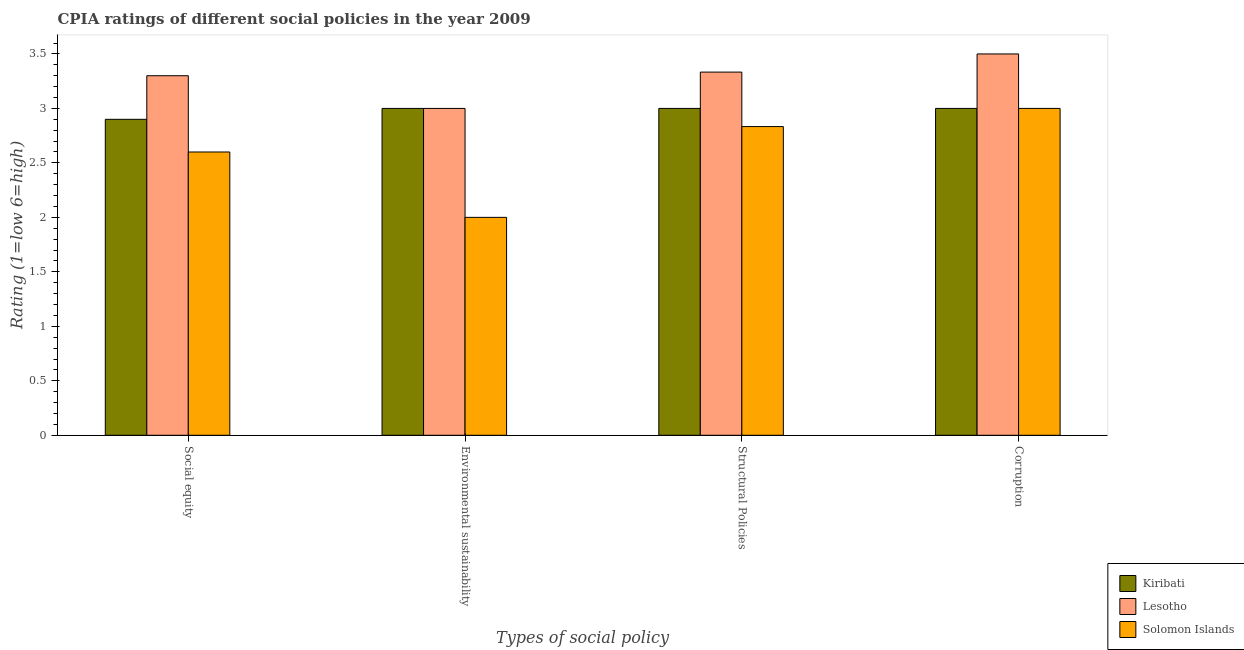How many groups of bars are there?
Your answer should be compact. 4. Are the number of bars on each tick of the X-axis equal?
Provide a succinct answer. Yes. How many bars are there on the 4th tick from the left?
Your answer should be compact. 3. How many bars are there on the 2nd tick from the right?
Offer a very short reply. 3. What is the label of the 2nd group of bars from the left?
Provide a short and direct response. Environmental sustainability. What is the cpia rating of structural policies in Solomon Islands?
Provide a short and direct response. 2.83. Across all countries, what is the maximum cpia rating of structural policies?
Offer a very short reply. 3.33. Across all countries, what is the minimum cpia rating of social equity?
Offer a terse response. 2.6. In which country was the cpia rating of social equity maximum?
Your answer should be compact. Lesotho. In which country was the cpia rating of environmental sustainability minimum?
Offer a very short reply. Solomon Islands. What is the total cpia rating of social equity in the graph?
Your response must be concise. 8.8. What is the difference between the cpia rating of structural policies in Lesotho and that in Kiribati?
Keep it short and to the point. 0.33. What is the difference between the cpia rating of structural policies in Kiribati and the cpia rating of social equity in Solomon Islands?
Give a very brief answer. 0.4. What is the average cpia rating of structural policies per country?
Offer a terse response. 3.06. What is the difference between the cpia rating of social equity and cpia rating of corruption in Kiribati?
Make the answer very short. -0.1. What is the ratio of the cpia rating of social equity in Lesotho to that in Solomon Islands?
Offer a terse response. 1.27. Is the difference between the cpia rating of social equity in Solomon Islands and Lesotho greater than the difference between the cpia rating of corruption in Solomon Islands and Lesotho?
Offer a terse response. No. What is the difference between the highest and the second highest cpia rating of social equity?
Provide a succinct answer. 0.4. What is the difference between the highest and the lowest cpia rating of structural policies?
Ensure brevity in your answer.  0.5. In how many countries, is the cpia rating of corruption greater than the average cpia rating of corruption taken over all countries?
Offer a terse response. 1. What does the 3rd bar from the left in Corruption represents?
Your answer should be very brief. Solomon Islands. What does the 2nd bar from the right in Structural Policies represents?
Offer a very short reply. Lesotho. How many bars are there?
Ensure brevity in your answer.  12. Does the graph contain any zero values?
Your answer should be very brief. No. How many legend labels are there?
Your response must be concise. 3. What is the title of the graph?
Your answer should be compact. CPIA ratings of different social policies in the year 2009. What is the label or title of the X-axis?
Make the answer very short. Types of social policy. What is the label or title of the Y-axis?
Provide a short and direct response. Rating (1=low 6=high). What is the Rating (1=low 6=high) in Kiribati in Social equity?
Your response must be concise. 2.9. What is the Rating (1=low 6=high) in Lesotho in Social equity?
Keep it short and to the point. 3.3. What is the Rating (1=low 6=high) in Kiribati in Environmental sustainability?
Provide a succinct answer. 3. What is the Rating (1=low 6=high) in Lesotho in Environmental sustainability?
Your answer should be compact. 3. What is the Rating (1=low 6=high) in Solomon Islands in Environmental sustainability?
Give a very brief answer. 2. What is the Rating (1=low 6=high) of Lesotho in Structural Policies?
Your answer should be compact. 3.33. What is the Rating (1=low 6=high) in Solomon Islands in Structural Policies?
Provide a succinct answer. 2.83. What is the Rating (1=low 6=high) in Kiribati in Corruption?
Provide a succinct answer. 3. What is the Rating (1=low 6=high) in Solomon Islands in Corruption?
Your response must be concise. 3. Across all Types of social policy, what is the maximum Rating (1=low 6=high) in Solomon Islands?
Keep it short and to the point. 3. Across all Types of social policy, what is the minimum Rating (1=low 6=high) in Lesotho?
Ensure brevity in your answer.  3. What is the total Rating (1=low 6=high) in Lesotho in the graph?
Ensure brevity in your answer.  13.13. What is the total Rating (1=low 6=high) in Solomon Islands in the graph?
Your answer should be very brief. 10.43. What is the difference between the Rating (1=low 6=high) in Kiribati in Social equity and that in Environmental sustainability?
Offer a terse response. -0.1. What is the difference between the Rating (1=low 6=high) in Lesotho in Social equity and that in Structural Policies?
Give a very brief answer. -0.03. What is the difference between the Rating (1=low 6=high) of Solomon Islands in Social equity and that in Structural Policies?
Your answer should be very brief. -0.23. What is the difference between the Rating (1=low 6=high) of Solomon Islands in Social equity and that in Corruption?
Make the answer very short. -0.4. What is the difference between the Rating (1=low 6=high) of Lesotho in Environmental sustainability and that in Structural Policies?
Offer a terse response. -0.33. What is the difference between the Rating (1=low 6=high) in Solomon Islands in Environmental sustainability and that in Structural Policies?
Your response must be concise. -0.83. What is the difference between the Rating (1=low 6=high) in Kiribati in Environmental sustainability and that in Corruption?
Your answer should be compact. 0. What is the difference between the Rating (1=low 6=high) in Lesotho in Environmental sustainability and that in Corruption?
Offer a terse response. -0.5. What is the difference between the Rating (1=low 6=high) of Solomon Islands in Environmental sustainability and that in Corruption?
Your answer should be compact. -1. What is the difference between the Rating (1=low 6=high) in Kiribati in Social equity and the Rating (1=low 6=high) in Lesotho in Environmental sustainability?
Your response must be concise. -0.1. What is the difference between the Rating (1=low 6=high) in Kiribati in Social equity and the Rating (1=low 6=high) in Solomon Islands in Environmental sustainability?
Offer a very short reply. 0.9. What is the difference between the Rating (1=low 6=high) in Lesotho in Social equity and the Rating (1=low 6=high) in Solomon Islands in Environmental sustainability?
Ensure brevity in your answer.  1.3. What is the difference between the Rating (1=low 6=high) in Kiribati in Social equity and the Rating (1=low 6=high) in Lesotho in Structural Policies?
Offer a very short reply. -0.43. What is the difference between the Rating (1=low 6=high) in Kiribati in Social equity and the Rating (1=low 6=high) in Solomon Islands in Structural Policies?
Offer a very short reply. 0.07. What is the difference between the Rating (1=low 6=high) of Lesotho in Social equity and the Rating (1=low 6=high) of Solomon Islands in Structural Policies?
Make the answer very short. 0.47. What is the difference between the Rating (1=low 6=high) in Kiribati in Social equity and the Rating (1=low 6=high) in Lesotho in Corruption?
Make the answer very short. -0.6. What is the difference between the Rating (1=low 6=high) of Kiribati in Social equity and the Rating (1=low 6=high) of Solomon Islands in Corruption?
Provide a short and direct response. -0.1. What is the difference between the Rating (1=low 6=high) of Kiribati in Environmental sustainability and the Rating (1=low 6=high) of Lesotho in Structural Policies?
Offer a terse response. -0.33. What is the difference between the Rating (1=low 6=high) of Kiribati in Environmental sustainability and the Rating (1=low 6=high) of Solomon Islands in Structural Policies?
Keep it short and to the point. 0.17. What is the difference between the Rating (1=low 6=high) in Lesotho in Environmental sustainability and the Rating (1=low 6=high) in Solomon Islands in Structural Policies?
Your answer should be compact. 0.17. What is the difference between the Rating (1=low 6=high) of Kiribati in Environmental sustainability and the Rating (1=low 6=high) of Lesotho in Corruption?
Your response must be concise. -0.5. What is the difference between the Rating (1=low 6=high) in Kiribati in Structural Policies and the Rating (1=low 6=high) in Solomon Islands in Corruption?
Offer a very short reply. 0. What is the average Rating (1=low 6=high) in Kiribati per Types of social policy?
Give a very brief answer. 2.98. What is the average Rating (1=low 6=high) in Lesotho per Types of social policy?
Your answer should be very brief. 3.28. What is the average Rating (1=low 6=high) of Solomon Islands per Types of social policy?
Offer a terse response. 2.61. What is the difference between the Rating (1=low 6=high) in Kiribati and Rating (1=low 6=high) in Lesotho in Social equity?
Make the answer very short. -0.4. What is the difference between the Rating (1=low 6=high) in Kiribati and Rating (1=low 6=high) in Lesotho in Environmental sustainability?
Provide a succinct answer. 0. What is the difference between the Rating (1=low 6=high) in Lesotho and Rating (1=low 6=high) in Solomon Islands in Environmental sustainability?
Your answer should be very brief. 1. What is the difference between the Rating (1=low 6=high) of Kiribati and Rating (1=low 6=high) of Solomon Islands in Structural Policies?
Offer a very short reply. 0.17. What is the difference between the Rating (1=low 6=high) of Lesotho and Rating (1=low 6=high) of Solomon Islands in Structural Policies?
Make the answer very short. 0.5. What is the difference between the Rating (1=low 6=high) of Kiribati and Rating (1=low 6=high) of Lesotho in Corruption?
Provide a succinct answer. -0.5. What is the ratio of the Rating (1=low 6=high) in Kiribati in Social equity to that in Environmental sustainability?
Your answer should be very brief. 0.97. What is the ratio of the Rating (1=low 6=high) of Lesotho in Social equity to that in Environmental sustainability?
Your answer should be very brief. 1.1. What is the ratio of the Rating (1=low 6=high) in Kiribati in Social equity to that in Structural Policies?
Your response must be concise. 0.97. What is the ratio of the Rating (1=low 6=high) of Lesotho in Social equity to that in Structural Policies?
Your response must be concise. 0.99. What is the ratio of the Rating (1=low 6=high) of Solomon Islands in Social equity to that in Structural Policies?
Your answer should be very brief. 0.92. What is the ratio of the Rating (1=low 6=high) in Kiribati in Social equity to that in Corruption?
Your response must be concise. 0.97. What is the ratio of the Rating (1=low 6=high) in Lesotho in Social equity to that in Corruption?
Provide a short and direct response. 0.94. What is the ratio of the Rating (1=low 6=high) in Solomon Islands in Social equity to that in Corruption?
Ensure brevity in your answer.  0.87. What is the ratio of the Rating (1=low 6=high) of Lesotho in Environmental sustainability to that in Structural Policies?
Make the answer very short. 0.9. What is the ratio of the Rating (1=low 6=high) in Solomon Islands in Environmental sustainability to that in Structural Policies?
Provide a succinct answer. 0.71. What is the ratio of the Rating (1=low 6=high) in Lesotho in Structural Policies to that in Corruption?
Your response must be concise. 0.95. What is the difference between the highest and the second highest Rating (1=low 6=high) in Kiribati?
Give a very brief answer. 0. What is the difference between the highest and the second highest Rating (1=low 6=high) in Lesotho?
Give a very brief answer. 0.17. What is the difference between the highest and the lowest Rating (1=low 6=high) in Lesotho?
Make the answer very short. 0.5. 